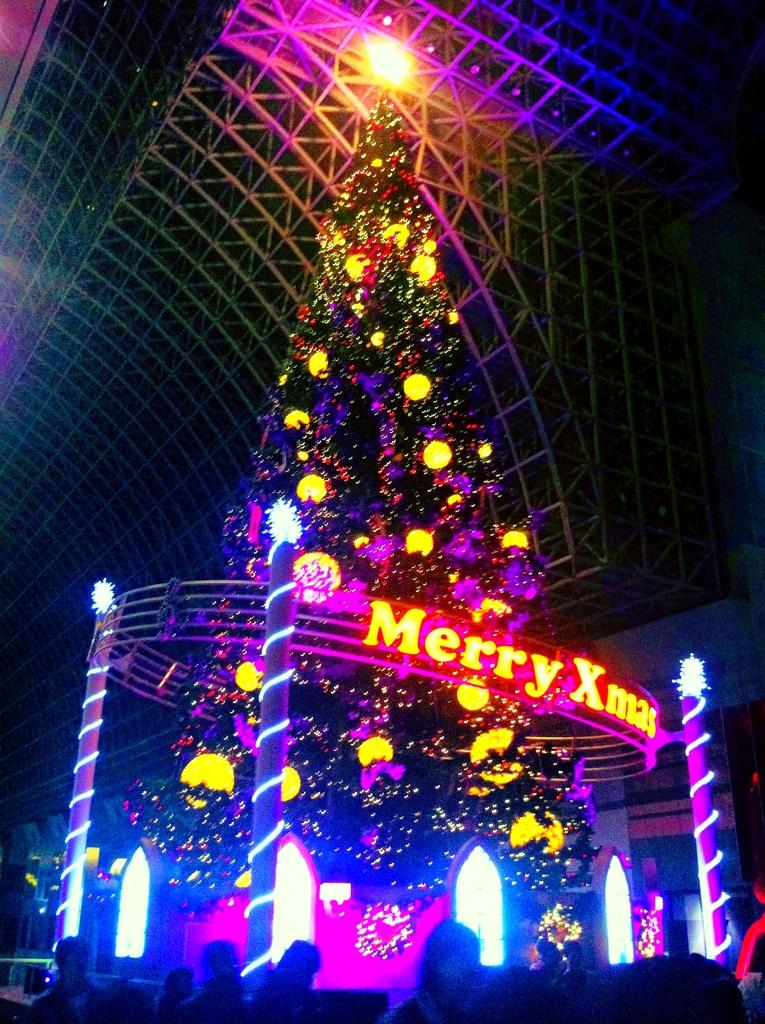Who or what is present in the image? There are people in the image. What can be seen in the image that provides illumination? There are lights in the image. What additional objects can be seen in the image? There are decorative items in the image. What type of tree is present in the image? There is a Christmas tree in the image. How would you describe the overall lighting in the image? The image is slightly dark. What type of coat is the road wearing in the image? There is no road present in the image, and therefore no coat can be associated with it. 